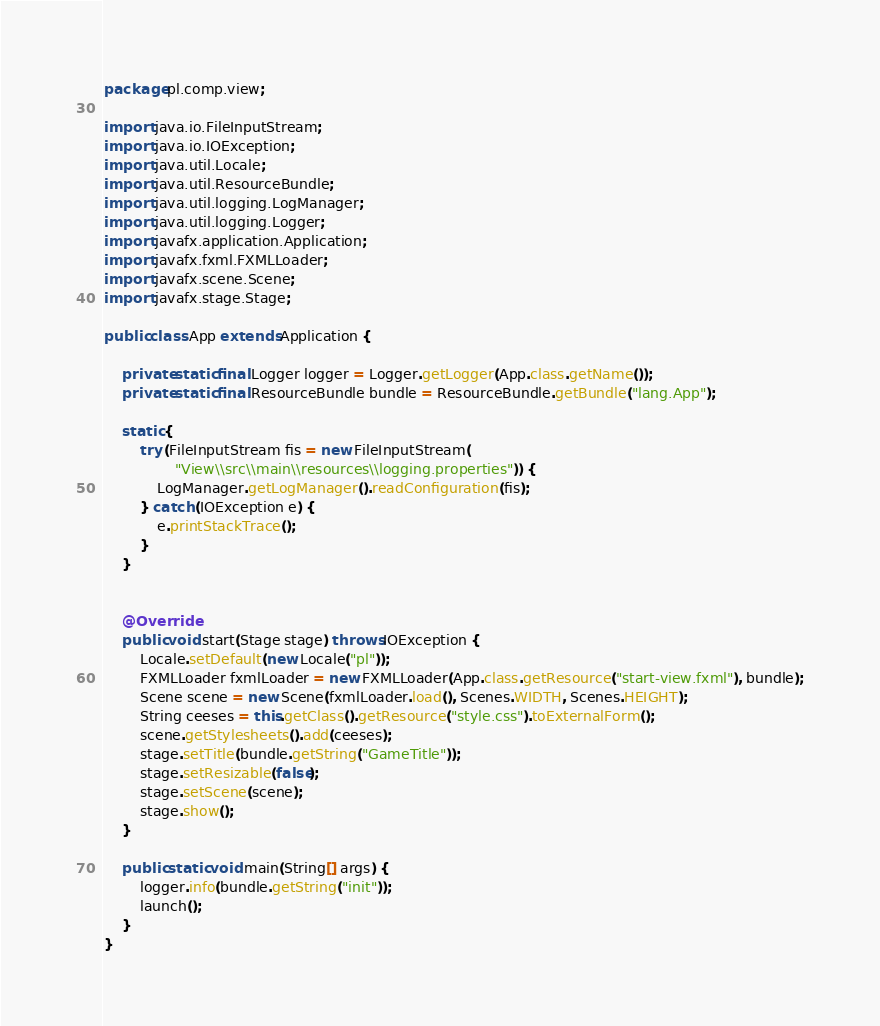Convert code to text. <code><loc_0><loc_0><loc_500><loc_500><_Java_>package pl.comp.view;

import java.io.FileInputStream;
import java.io.IOException;
import java.util.Locale;
import java.util.ResourceBundle;
import java.util.logging.LogManager;
import java.util.logging.Logger;
import javafx.application.Application;
import javafx.fxml.FXMLLoader;
import javafx.scene.Scene;
import javafx.stage.Stage;

public class App extends Application {

    private static final Logger logger = Logger.getLogger(App.class.getName());
    private static final ResourceBundle bundle = ResourceBundle.getBundle("lang.App");

    static {
        try (FileInputStream fis = new FileInputStream(
                "View\\src\\main\\resources\\logging.properties")) {
            LogManager.getLogManager().readConfiguration(fis);
        } catch (IOException e) {
            e.printStackTrace();
        }
    }


    @Override
    public void start(Stage stage) throws IOException {
        Locale.setDefault(new Locale("pl"));
        FXMLLoader fxmlLoader = new FXMLLoader(App.class.getResource("start-view.fxml"), bundle);
        Scene scene = new Scene(fxmlLoader.load(), Scenes.WIDTH, Scenes.HEIGHT);
        String ceeses = this.getClass().getResource("style.css").toExternalForm();
        scene.getStylesheets().add(ceeses);
        stage.setTitle(bundle.getString("GameTitle"));
        stage.setResizable(false);
        stage.setScene(scene);
        stage.show();
    }

    public static void main(String[] args) {
        logger.info(bundle.getString("init"));
        launch();
    }
}</code> 